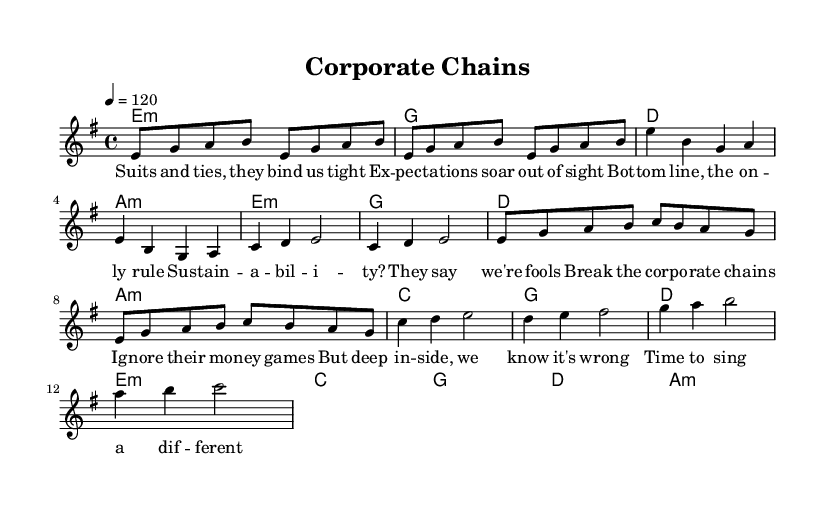What is the key signature of this music? The key signature is E minor, which is indicated by the presence of one sharp in the key signature, consisting of F sharp.
Answer: E minor What is the time signature of this piece? The time signature is 4/4, which is displayed to the left of the staff, indicating four beats per measure.
Answer: 4/4 What is the tempo marking of the piece? The tempo marking shows a tempo of 120 beats per minute, which is placed above the staff to indicate the speed of the music.
Answer: 120 How many measures are in the verse? The verse contains four measures, identifiable through the separation of the music notation into distinct groups that have been counted.
Answer: 4 What chord follows the chorus? The chord following the chorus is C major, which can be found in the harmony section just after the chorus section.
Answer: C What theme does the lyrics of this song convey? The song's lyrics convey a theme of rebellion against corporate pressures and societal expectations, as reflected in the lines discussing corporate chains and the desire for change.
Answer: Rebellion What musical section follows the intro? The section that follows the intro is the verse, indicated by the transition in the melody and the lyrics that begin after the initial introduction of the music.
Answer: Verse 